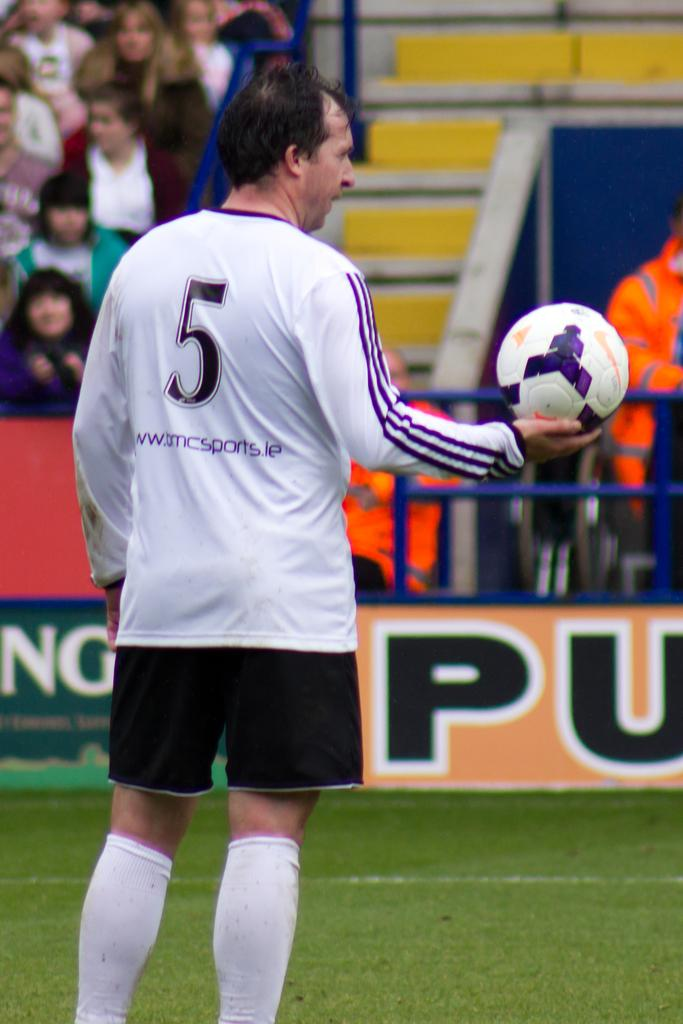<image>
Offer a succinct explanation of the picture presented. A man wearing a white number 5 jersey holding the soccer ball in his right hand. 